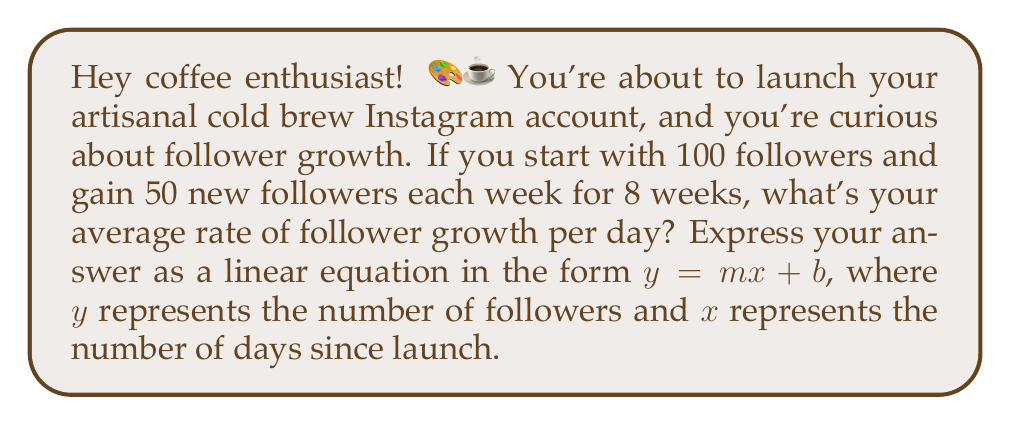What is the answer to this math problem? Alright, let's break this down step-by-step:

1) First, let's identify our variables:
   $y$ = number of followers
   $x$ = number of days since launch

2) We start with 100 followers, so our y-intercept (b) is 100.

3) We gain 50 followers per week for 8 weeks. To find the daily rate:
   $\frac{50 \text{ followers}}{\text{7 days}} \approx 7.14285714 \text{ followers per day}$

4) This daily rate is our slope (m).

5) Now we can form our linear equation:
   $y = 7.14285714x + 100$

6) To verify, let's check the number of followers after 8 weeks (56 days):
   $y = 7.14285714(56) + 100 = 500$

   This matches our expectation: 
   $100 \text{ (initial)} + (50 \times 8 \text{ weeks}) = 500 \text{ followers}$

Therefore, the average rate of follower growth per day can be expressed as the linear equation $y = 7.14285714x + 100$, where $y$ is the number of followers and $x$ is the number of days since launch.
Answer: $y = 7.14285714x + 100$ 